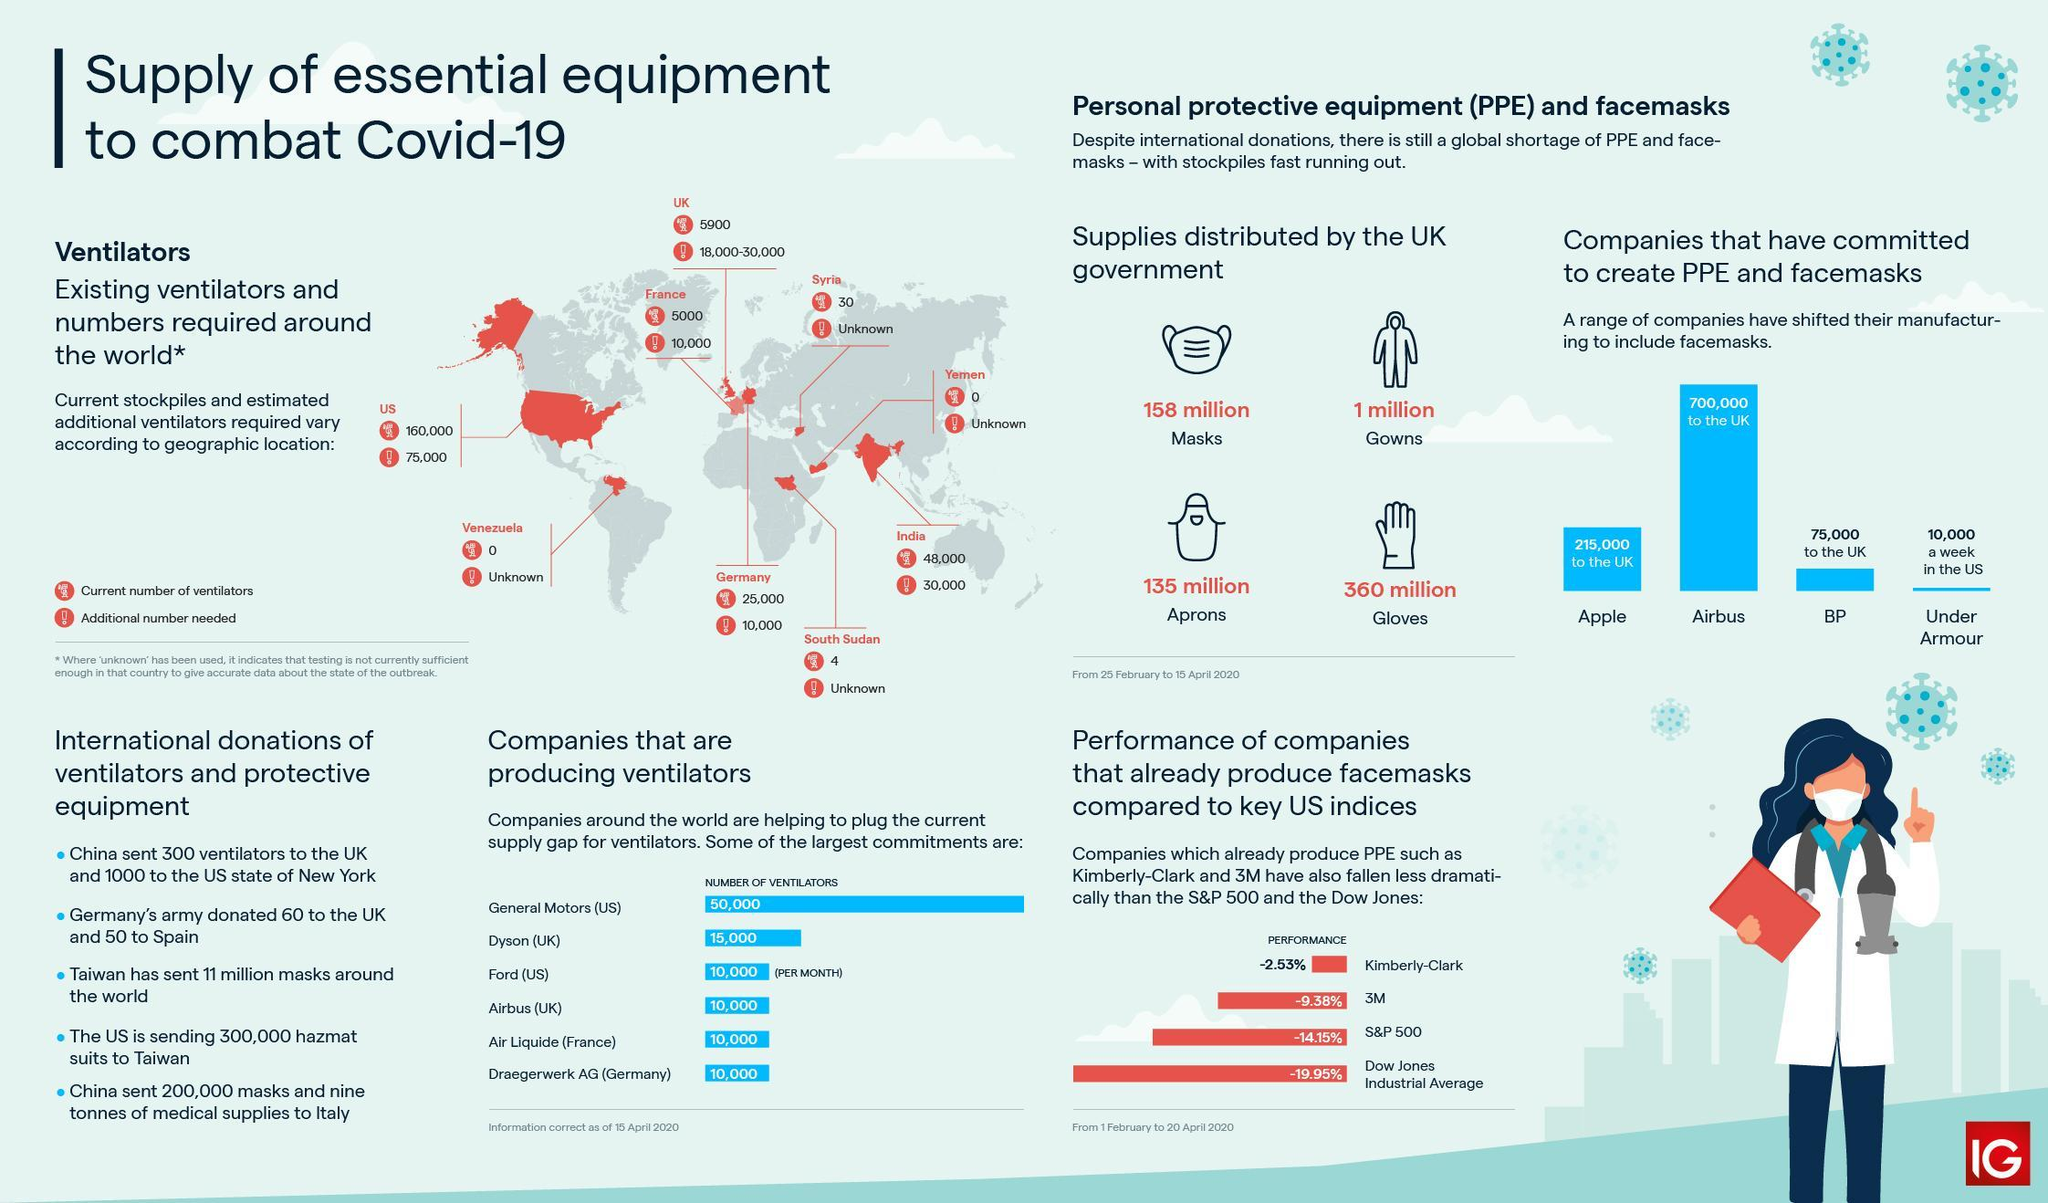Draw attention to some important aspects in this diagram. India requires approximately 30,000 additional ventilators to combat the COVID-19 pandemic. It is estimated that 75,000 additional ventilators are necessary in the United States to effectively combat the COVID-19 pandemic. There are approximately 25,000 ventilators currently available in Germany. As of 2021, there are approximately 5,900 ventilators currently available in the United Kingdom. The UK government distributed a total of 158 million masks from 25 February to 15 April 2020. 